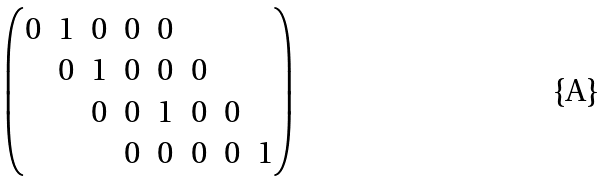<formula> <loc_0><loc_0><loc_500><loc_500>\begin{pmatrix} 0 & 1 & 0 & 0 & 0 \\ & 0 & 1 & 0 & 0 & 0 & \\ & & 0 & 0 & 1 & 0 & 0 \\ & & & 0 & 0 & 0 & 0 & 1 \end{pmatrix}</formula> 